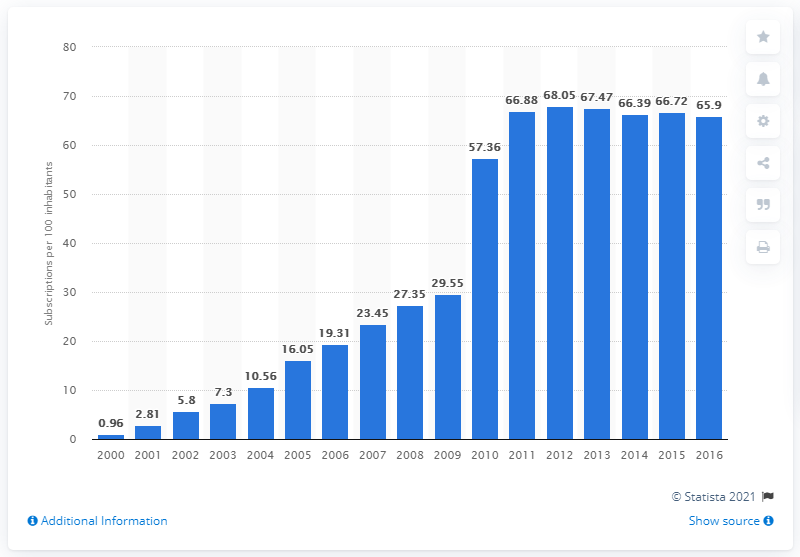Indicate a few pertinent items in this graphic. From 2000 to 2016, there were an average of 65.9 mobile subscriptions registered for every 100 people in Equatorial Guinea. As of 2000, the number of mobile cellular subscriptions per 100 inhabitants in Equatorial Guinea was X. 